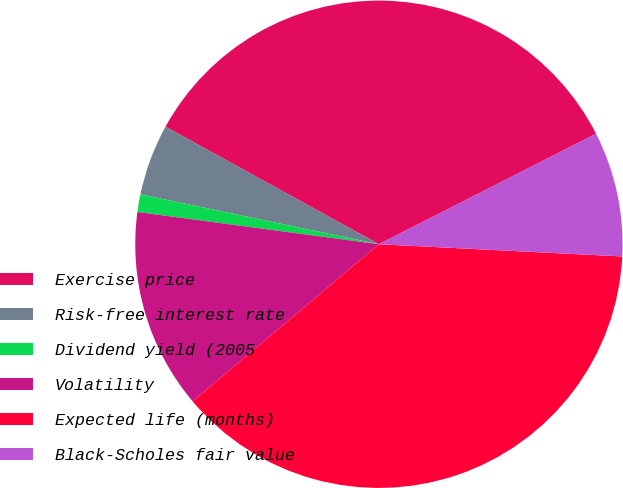<chart> <loc_0><loc_0><loc_500><loc_500><pie_chart><fcel>Exercise price<fcel>Risk-free interest rate<fcel>Dividend yield (2005<fcel>Volatility<fcel>Expected life (months)<fcel>Black-Scholes fair value<nl><fcel>34.49%<fcel>4.73%<fcel>1.17%<fcel>13.26%<fcel>38.05%<fcel>8.29%<nl></chart> 